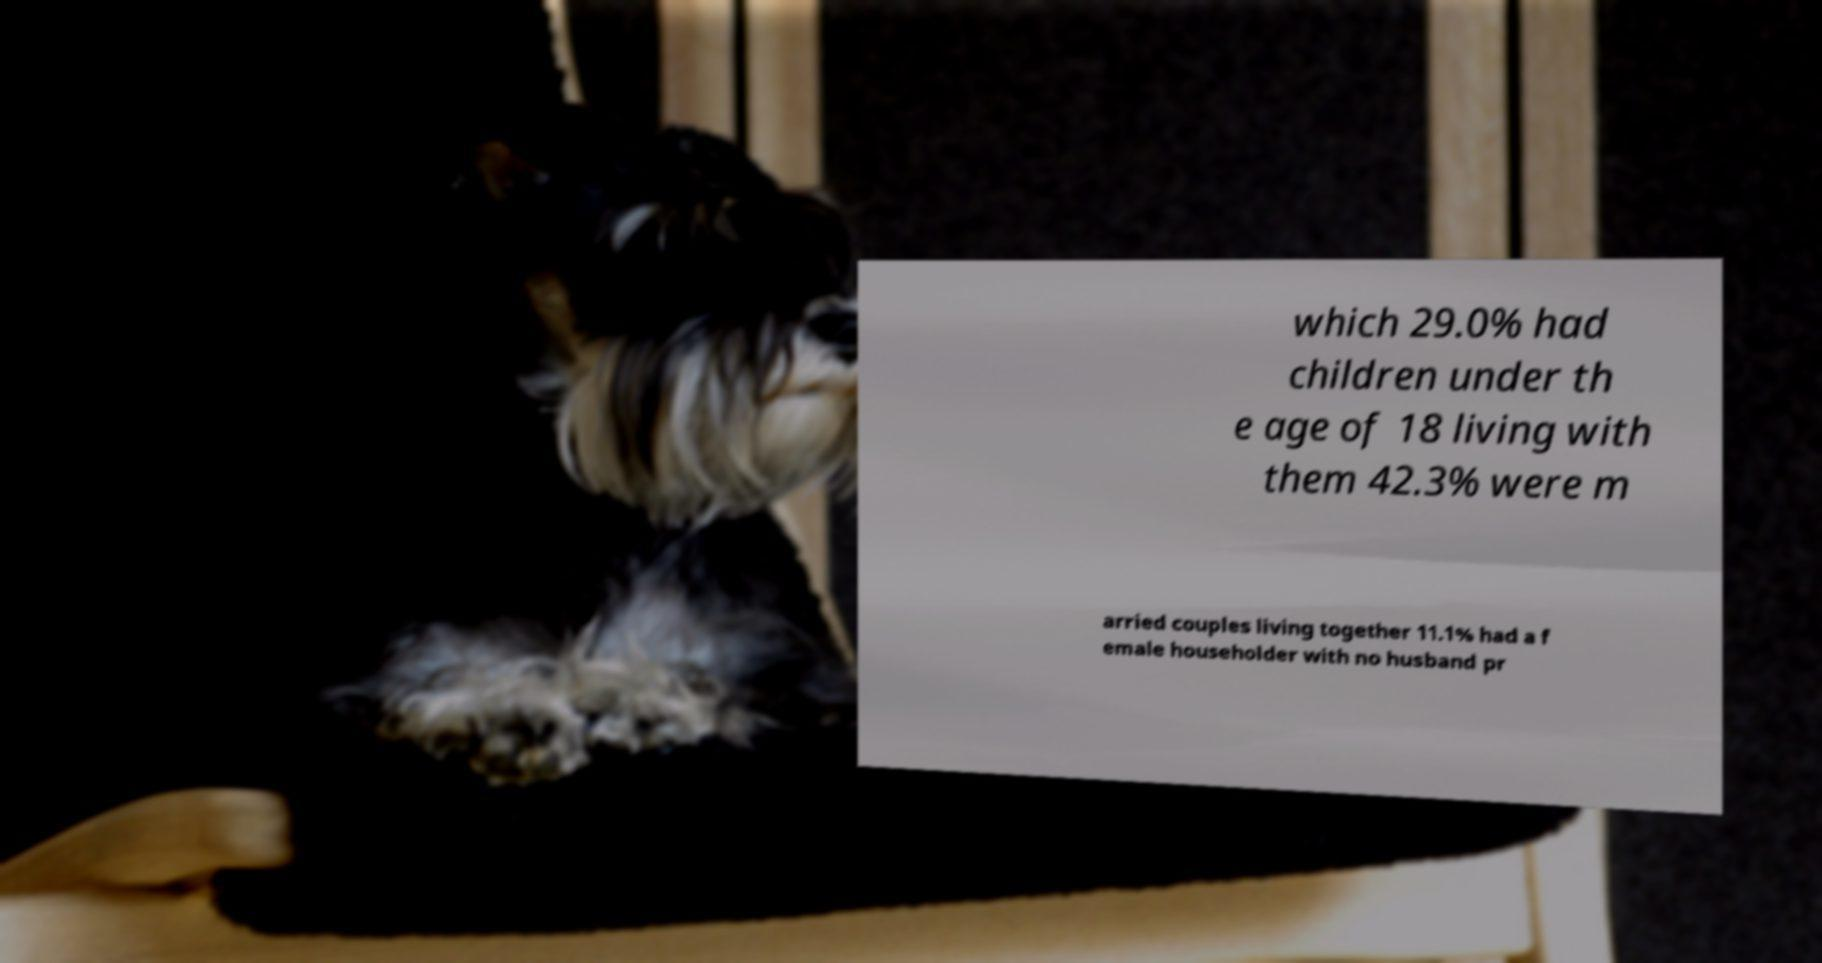Could you extract and type out the text from this image? which 29.0% had children under th e age of 18 living with them 42.3% were m arried couples living together 11.1% had a f emale householder with no husband pr 